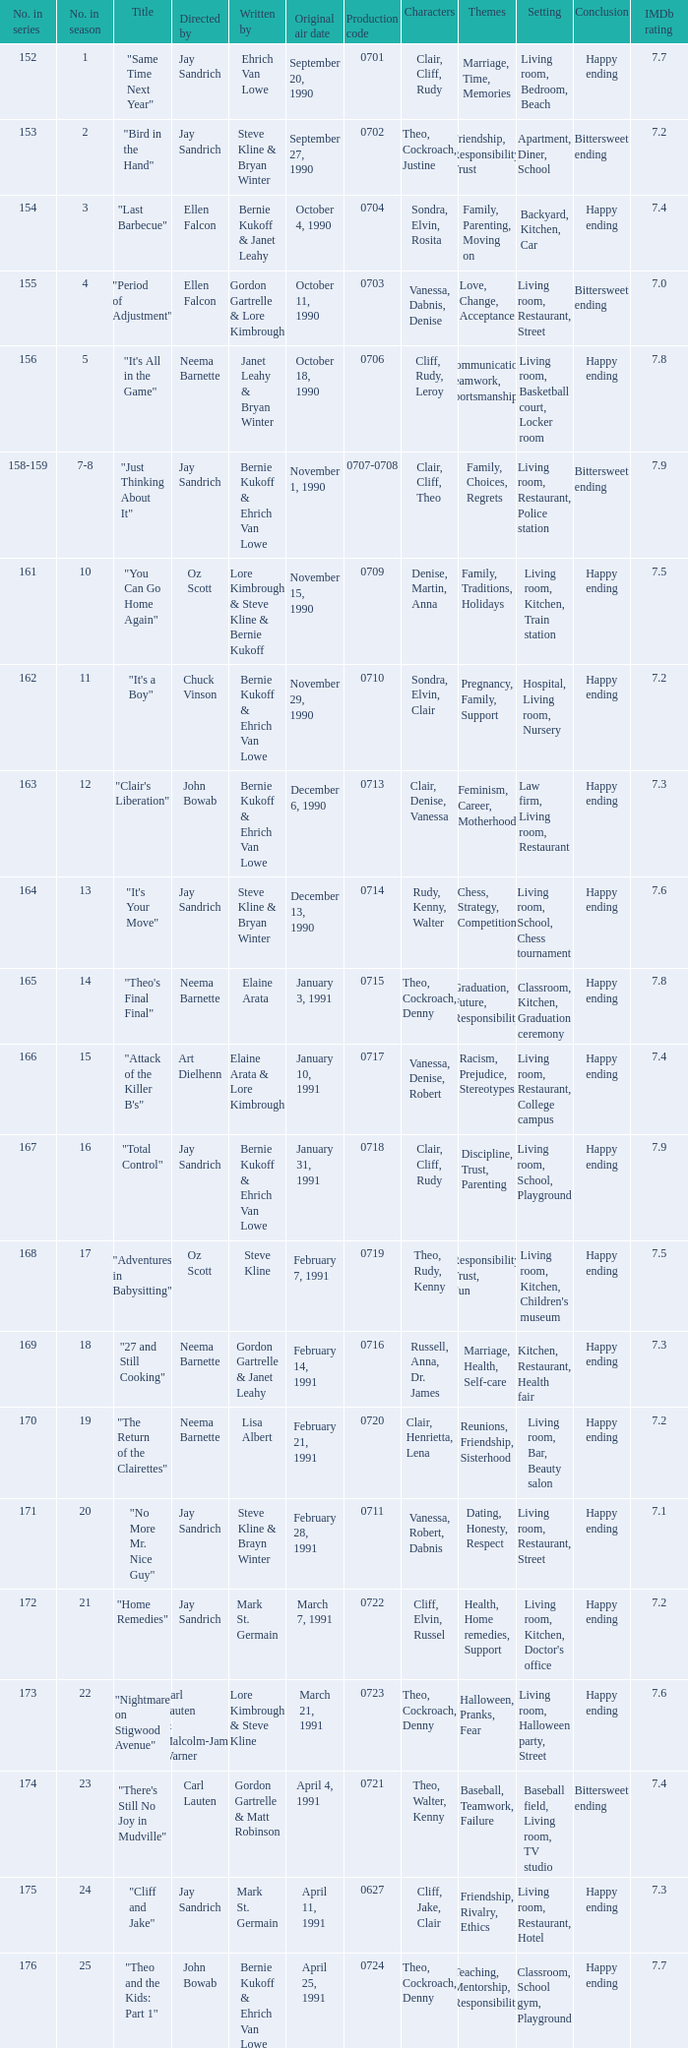The episode "adventures in babysitting" had what number in the season? 17.0. 